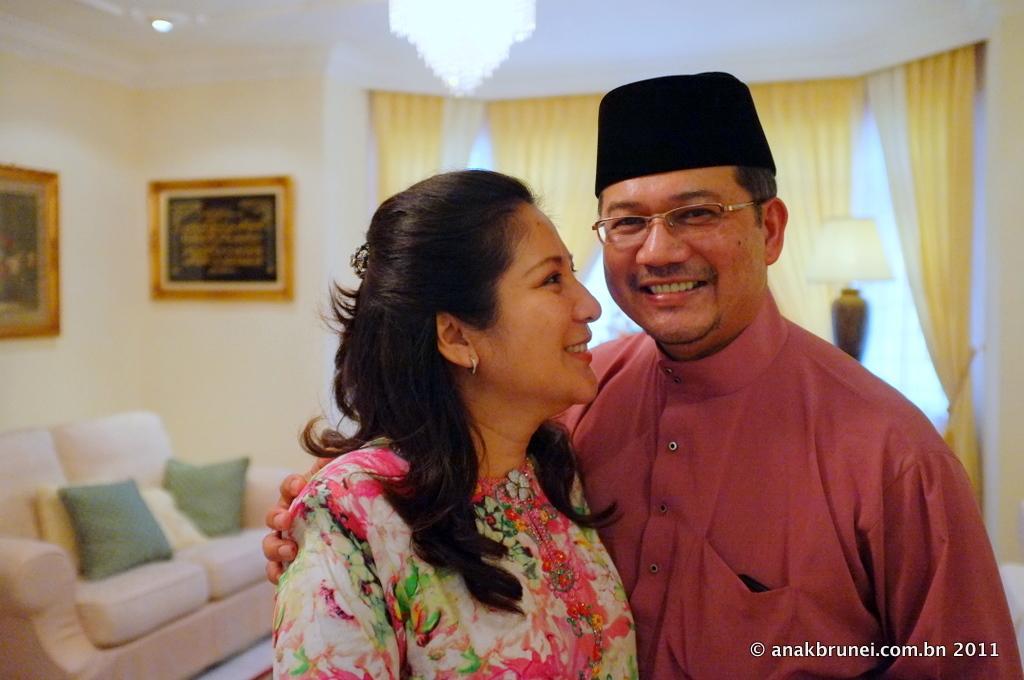Describe this image in one or two sentences. This image is taken indoors. In the background there is a wall with a window and two picture frames on it and there are two curtains. There is a lamp. At the top of the image there is a ceiling with a light and there is a chandelier. On the left side of the image there is a couch with a few pillows on it. In the middle of the image a man and a woman are standing and they are with smiling faces. 